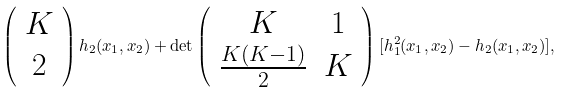<formula> <loc_0><loc_0><loc_500><loc_500>\left ( \begin{array} { c } K \\ 2 \end{array} \right ) h _ { 2 } ( x _ { 1 } , x _ { 2 } ) + \det \left ( \begin{array} { c c } K & 1 \\ \frac { K ( K - 1 ) } { 2 } & K \end{array} \right ) [ h _ { 1 } ^ { 2 } ( x _ { 1 } , x _ { 2 } ) - h _ { 2 } ( x _ { 1 } , x _ { 2 } ) ] ,</formula> 